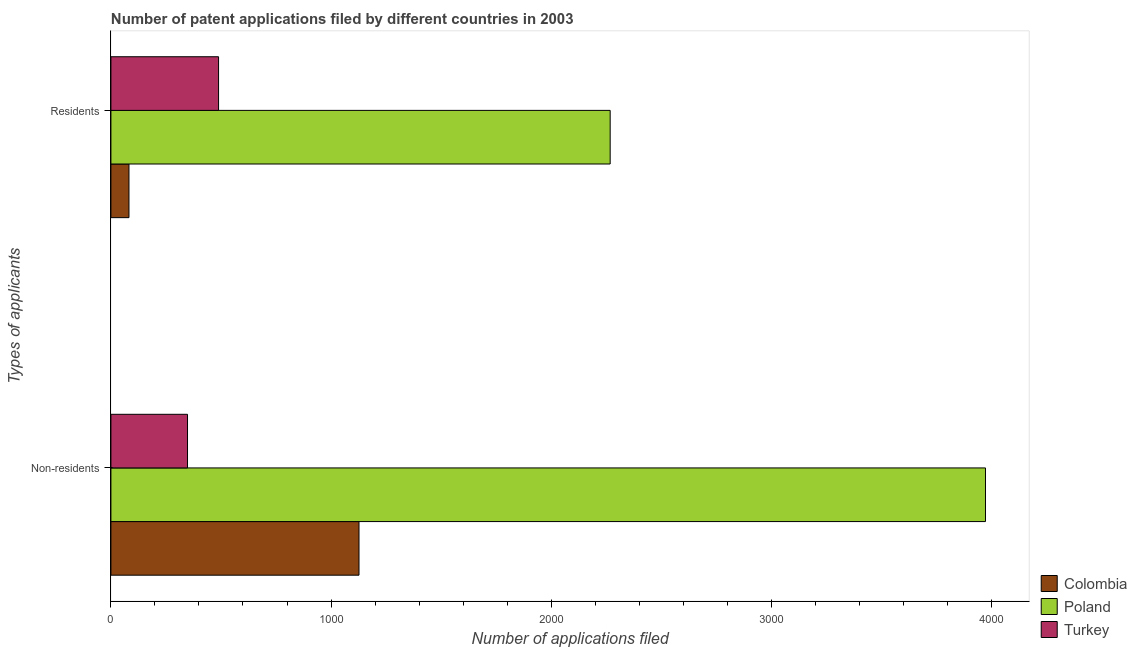How many groups of bars are there?
Keep it short and to the point. 2. Are the number of bars per tick equal to the number of legend labels?
Keep it short and to the point. Yes. How many bars are there on the 2nd tick from the bottom?
Keep it short and to the point. 3. What is the label of the 1st group of bars from the top?
Provide a succinct answer. Residents. What is the number of patent applications by residents in Poland?
Provide a succinct answer. 2268. Across all countries, what is the maximum number of patent applications by residents?
Your answer should be compact. 2268. Across all countries, what is the minimum number of patent applications by residents?
Offer a very short reply. 82. In which country was the number of patent applications by residents maximum?
Provide a short and direct response. Poland. What is the total number of patent applications by residents in the graph?
Provide a short and direct response. 2839. What is the difference between the number of patent applications by non residents in Poland and that in Turkey?
Your answer should be compact. 3625. What is the difference between the number of patent applications by non residents in Colombia and the number of patent applications by residents in Poland?
Your answer should be compact. -1141. What is the average number of patent applications by non residents per country?
Keep it short and to the point. 1816. What is the difference between the number of patent applications by non residents and number of patent applications by residents in Poland?
Ensure brevity in your answer.  1705. What is the ratio of the number of patent applications by residents in Turkey to that in Colombia?
Make the answer very short. 5.96. In how many countries, is the number of patent applications by residents greater than the average number of patent applications by residents taken over all countries?
Provide a short and direct response. 1. What does the 2nd bar from the top in Non-residents represents?
Your answer should be compact. Poland. What is the difference between two consecutive major ticks on the X-axis?
Offer a terse response. 1000. Does the graph contain grids?
Make the answer very short. No. Where does the legend appear in the graph?
Keep it short and to the point. Bottom right. How many legend labels are there?
Give a very brief answer. 3. What is the title of the graph?
Make the answer very short. Number of patent applications filed by different countries in 2003. Does "Indonesia" appear as one of the legend labels in the graph?
Offer a terse response. No. What is the label or title of the X-axis?
Ensure brevity in your answer.  Number of applications filed. What is the label or title of the Y-axis?
Provide a short and direct response. Types of applicants. What is the Number of applications filed in Colombia in Non-residents?
Make the answer very short. 1127. What is the Number of applications filed of Poland in Non-residents?
Provide a succinct answer. 3973. What is the Number of applications filed in Turkey in Non-residents?
Ensure brevity in your answer.  348. What is the Number of applications filed of Colombia in Residents?
Give a very brief answer. 82. What is the Number of applications filed in Poland in Residents?
Provide a succinct answer. 2268. What is the Number of applications filed of Turkey in Residents?
Your answer should be very brief. 489. Across all Types of applicants, what is the maximum Number of applications filed in Colombia?
Give a very brief answer. 1127. Across all Types of applicants, what is the maximum Number of applications filed of Poland?
Your response must be concise. 3973. Across all Types of applicants, what is the maximum Number of applications filed in Turkey?
Give a very brief answer. 489. Across all Types of applicants, what is the minimum Number of applications filed of Poland?
Ensure brevity in your answer.  2268. Across all Types of applicants, what is the minimum Number of applications filed of Turkey?
Your response must be concise. 348. What is the total Number of applications filed in Colombia in the graph?
Give a very brief answer. 1209. What is the total Number of applications filed in Poland in the graph?
Make the answer very short. 6241. What is the total Number of applications filed in Turkey in the graph?
Your response must be concise. 837. What is the difference between the Number of applications filed of Colombia in Non-residents and that in Residents?
Your answer should be compact. 1045. What is the difference between the Number of applications filed of Poland in Non-residents and that in Residents?
Your answer should be compact. 1705. What is the difference between the Number of applications filed of Turkey in Non-residents and that in Residents?
Offer a terse response. -141. What is the difference between the Number of applications filed of Colombia in Non-residents and the Number of applications filed of Poland in Residents?
Your answer should be compact. -1141. What is the difference between the Number of applications filed in Colombia in Non-residents and the Number of applications filed in Turkey in Residents?
Keep it short and to the point. 638. What is the difference between the Number of applications filed in Poland in Non-residents and the Number of applications filed in Turkey in Residents?
Your response must be concise. 3484. What is the average Number of applications filed of Colombia per Types of applicants?
Your answer should be compact. 604.5. What is the average Number of applications filed in Poland per Types of applicants?
Ensure brevity in your answer.  3120.5. What is the average Number of applications filed in Turkey per Types of applicants?
Keep it short and to the point. 418.5. What is the difference between the Number of applications filed of Colombia and Number of applications filed of Poland in Non-residents?
Offer a terse response. -2846. What is the difference between the Number of applications filed in Colombia and Number of applications filed in Turkey in Non-residents?
Your answer should be very brief. 779. What is the difference between the Number of applications filed in Poland and Number of applications filed in Turkey in Non-residents?
Give a very brief answer. 3625. What is the difference between the Number of applications filed of Colombia and Number of applications filed of Poland in Residents?
Keep it short and to the point. -2186. What is the difference between the Number of applications filed in Colombia and Number of applications filed in Turkey in Residents?
Provide a succinct answer. -407. What is the difference between the Number of applications filed of Poland and Number of applications filed of Turkey in Residents?
Provide a succinct answer. 1779. What is the ratio of the Number of applications filed of Colombia in Non-residents to that in Residents?
Give a very brief answer. 13.74. What is the ratio of the Number of applications filed of Poland in Non-residents to that in Residents?
Your answer should be very brief. 1.75. What is the ratio of the Number of applications filed of Turkey in Non-residents to that in Residents?
Offer a terse response. 0.71. What is the difference between the highest and the second highest Number of applications filed in Colombia?
Give a very brief answer. 1045. What is the difference between the highest and the second highest Number of applications filed of Poland?
Your answer should be compact. 1705. What is the difference between the highest and the second highest Number of applications filed in Turkey?
Your answer should be compact. 141. What is the difference between the highest and the lowest Number of applications filed in Colombia?
Make the answer very short. 1045. What is the difference between the highest and the lowest Number of applications filed of Poland?
Provide a short and direct response. 1705. What is the difference between the highest and the lowest Number of applications filed of Turkey?
Your answer should be very brief. 141. 